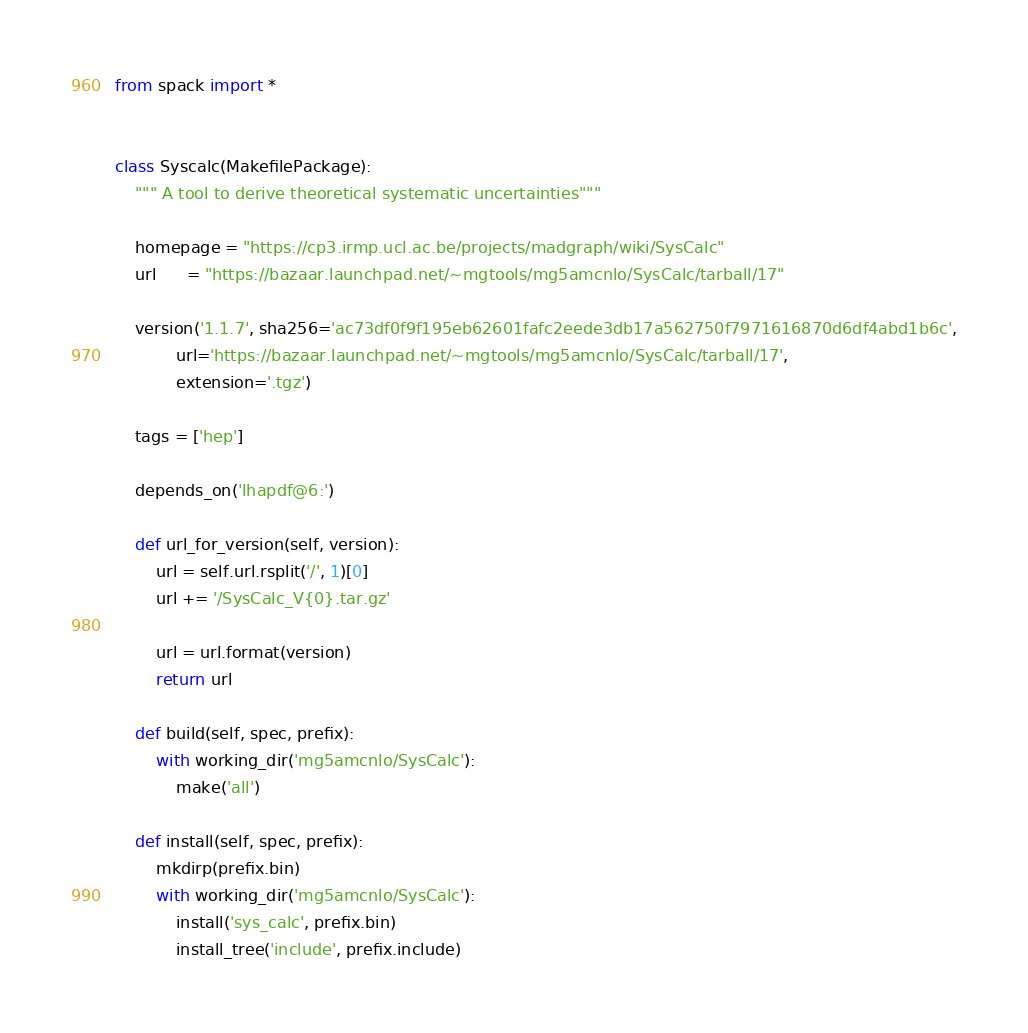<code> <loc_0><loc_0><loc_500><loc_500><_Python_>from spack import *


class Syscalc(MakefilePackage):
    """ A tool to derive theoretical systematic uncertainties"""

    homepage = "https://cp3.irmp.ucl.ac.be/projects/madgraph/wiki/SysCalc"
    url      = "https://bazaar.launchpad.net/~mgtools/mg5amcnlo/SysCalc/tarball/17"

    version('1.1.7', sha256='ac73df0f9f195eb62601fafc2eede3db17a562750f7971616870d6df4abd1b6c',
            url='https://bazaar.launchpad.net/~mgtools/mg5amcnlo/SysCalc/tarball/17',
            extension='.tgz')

    tags = ['hep']

    depends_on('lhapdf@6:')

    def url_for_version(self, version):
        url = self.url.rsplit('/', 1)[0]
        url += '/SysCalc_V{0}.tar.gz'

        url = url.format(version)
        return url

    def build(self, spec, prefix):
        with working_dir('mg5amcnlo/SysCalc'):
            make('all')

    def install(self, spec, prefix):
        mkdirp(prefix.bin)
        with working_dir('mg5amcnlo/SysCalc'):
            install('sys_calc', prefix.bin)
            install_tree('include', prefix.include)
</code> 